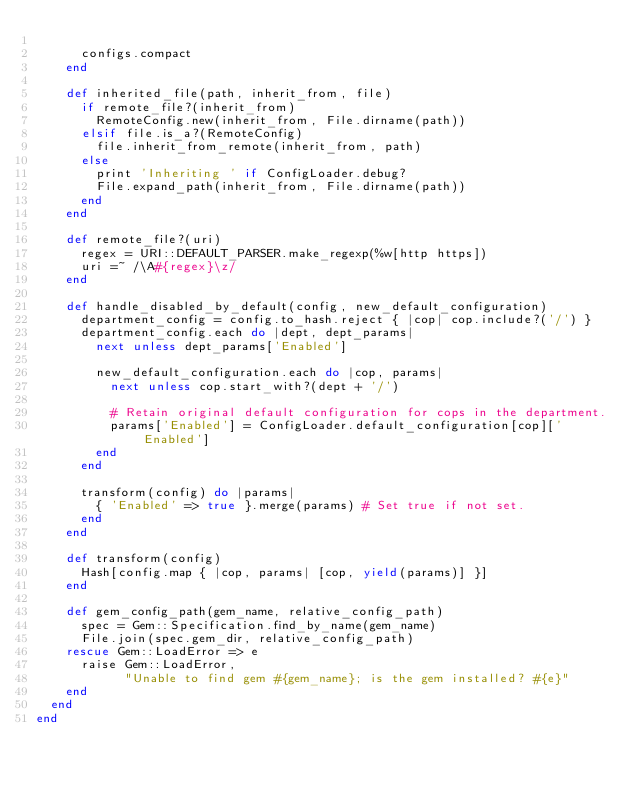Convert code to text. <code><loc_0><loc_0><loc_500><loc_500><_Ruby_>
      configs.compact
    end

    def inherited_file(path, inherit_from, file)
      if remote_file?(inherit_from)
        RemoteConfig.new(inherit_from, File.dirname(path))
      elsif file.is_a?(RemoteConfig)
        file.inherit_from_remote(inherit_from, path)
      else
        print 'Inheriting ' if ConfigLoader.debug?
        File.expand_path(inherit_from, File.dirname(path))
      end
    end

    def remote_file?(uri)
      regex = URI::DEFAULT_PARSER.make_regexp(%w[http https])
      uri =~ /\A#{regex}\z/
    end

    def handle_disabled_by_default(config, new_default_configuration)
      department_config = config.to_hash.reject { |cop| cop.include?('/') }
      department_config.each do |dept, dept_params|
        next unless dept_params['Enabled']

        new_default_configuration.each do |cop, params|
          next unless cop.start_with?(dept + '/')

          # Retain original default configuration for cops in the department.
          params['Enabled'] = ConfigLoader.default_configuration[cop]['Enabled']
        end
      end

      transform(config) do |params|
        { 'Enabled' => true }.merge(params) # Set true if not set.
      end
    end

    def transform(config)
      Hash[config.map { |cop, params| [cop, yield(params)] }]
    end

    def gem_config_path(gem_name, relative_config_path)
      spec = Gem::Specification.find_by_name(gem_name)
      File.join(spec.gem_dir, relative_config_path)
    rescue Gem::LoadError => e
      raise Gem::LoadError,
            "Unable to find gem #{gem_name}; is the gem installed? #{e}"
    end
  end
end
</code> 